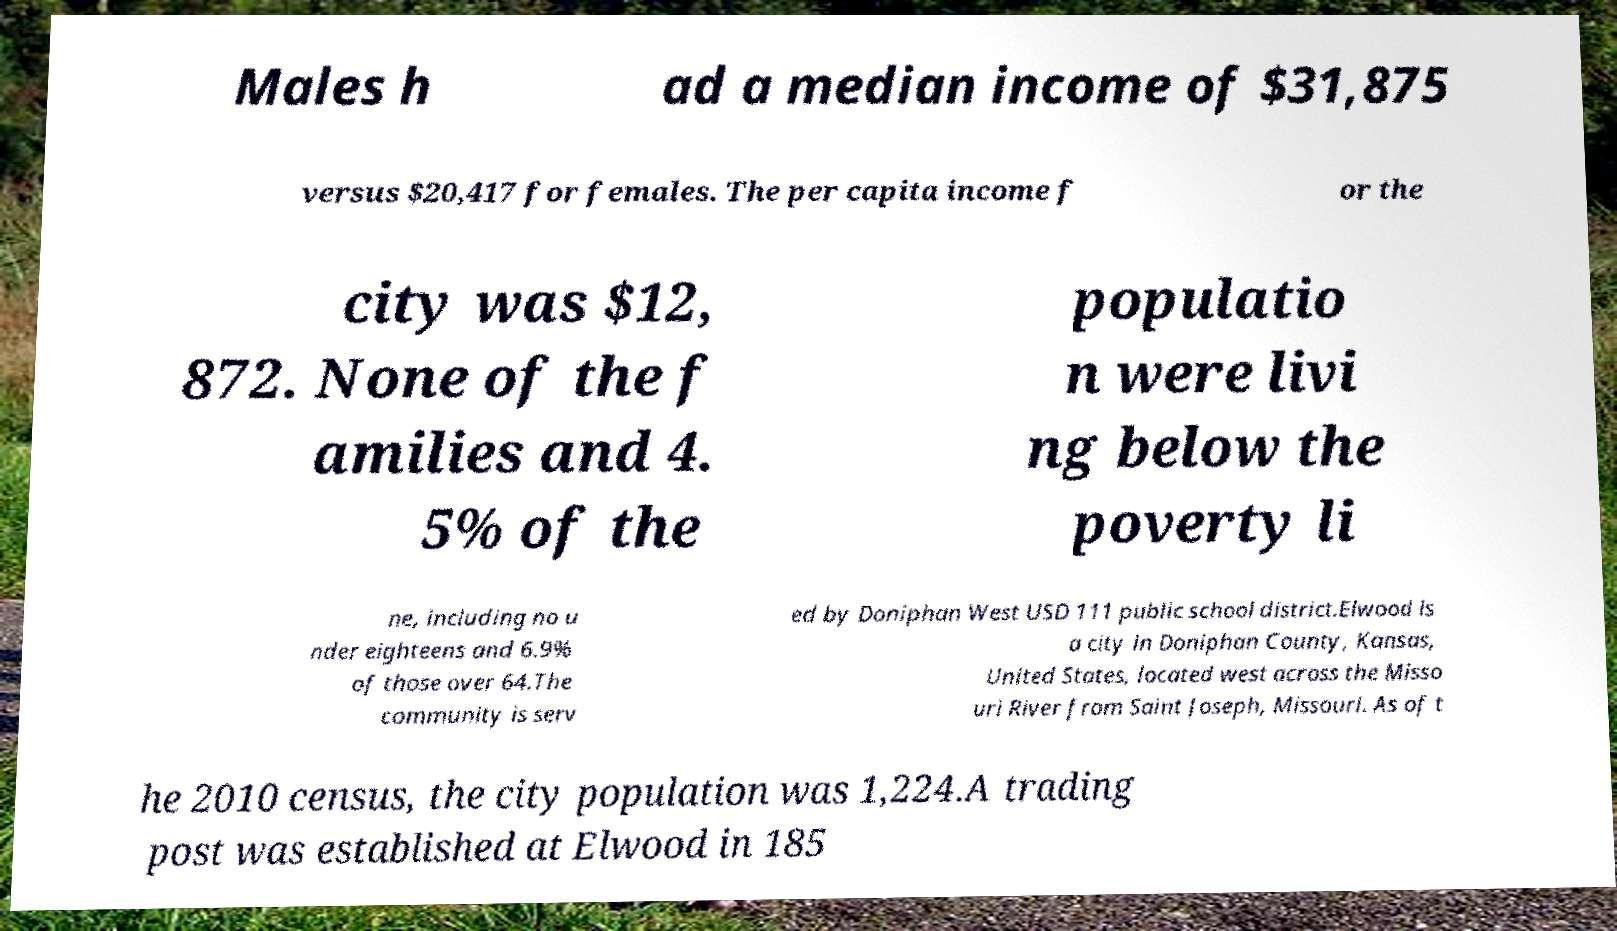There's text embedded in this image that I need extracted. Can you transcribe it verbatim? Males h ad a median income of $31,875 versus $20,417 for females. The per capita income f or the city was $12, 872. None of the f amilies and 4. 5% of the populatio n were livi ng below the poverty li ne, including no u nder eighteens and 6.9% of those over 64.The community is serv ed by Doniphan West USD 111 public school district.Elwood is a city in Doniphan County, Kansas, United States, located west across the Misso uri River from Saint Joseph, Missouri. As of t he 2010 census, the city population was 1,224.A trading post was established at Elwood in 185 